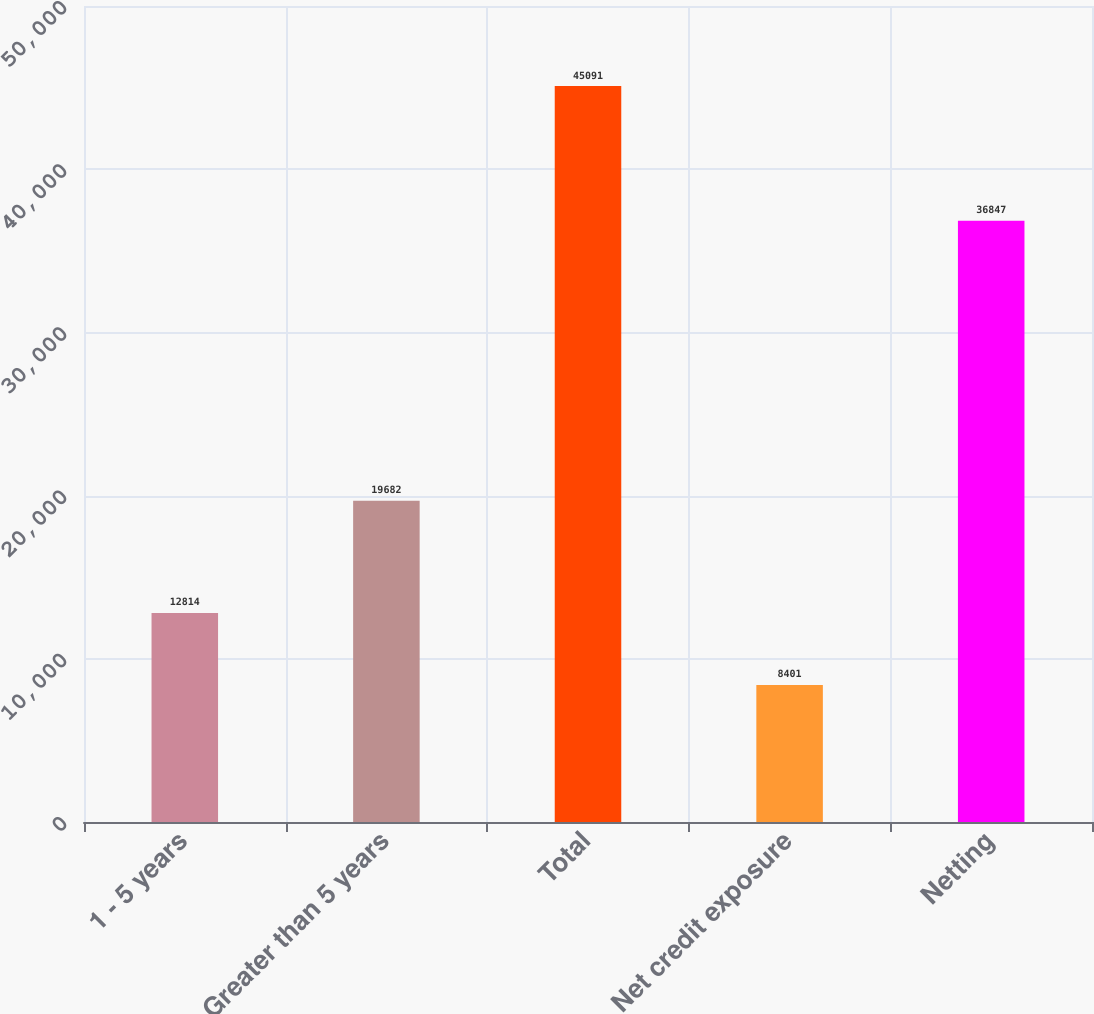Convert chart. <chart><loc_0><loc_0><loc_500><loc_500><bar_chart><fcel>1 - 5 years<fcel>Greater than 5 years<fcel>Total<fcel>Net credit exposure<fcel>Netting<nl><fcel>12814<fcel>19682<fcel>45091<fcel>8401<fcel>36847<nl></chart> 